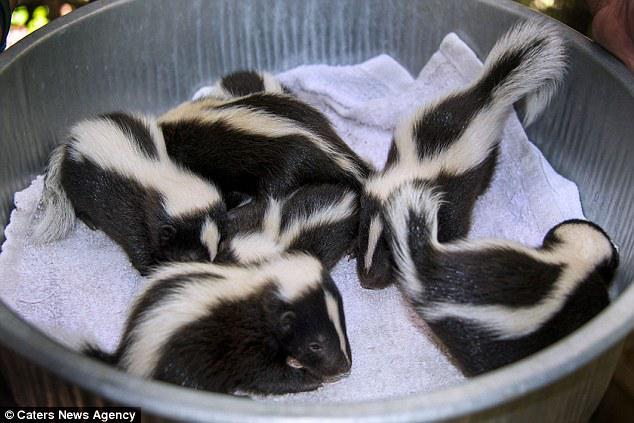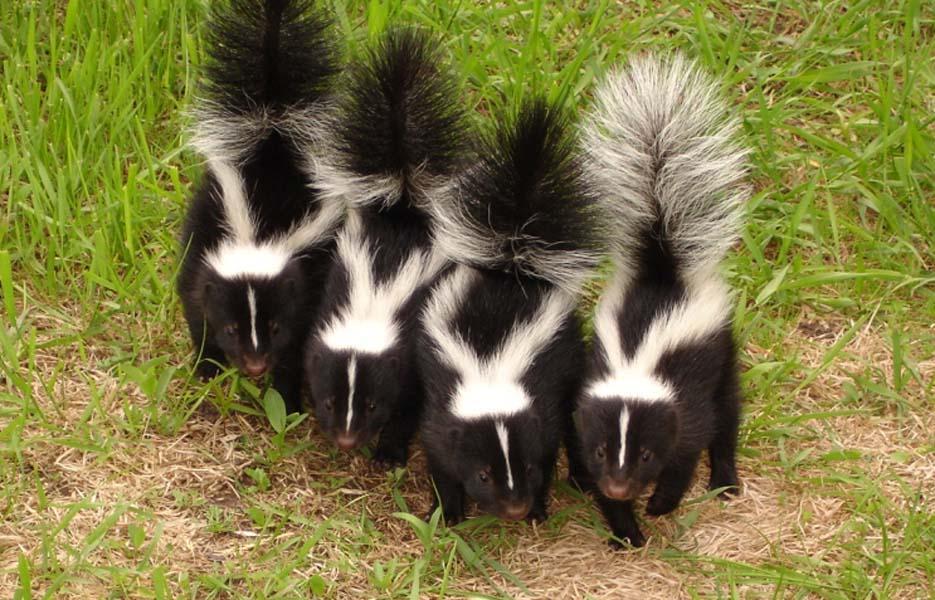The first image is the image on the left, the second image is the image on the right. For the images displayed, is the sentence "At least one skunk is eating." factually correct? Answer yes or no. No. 